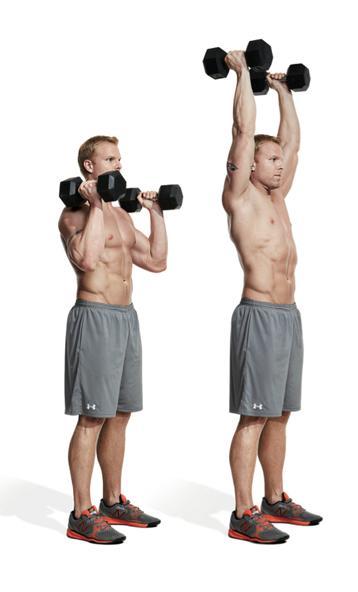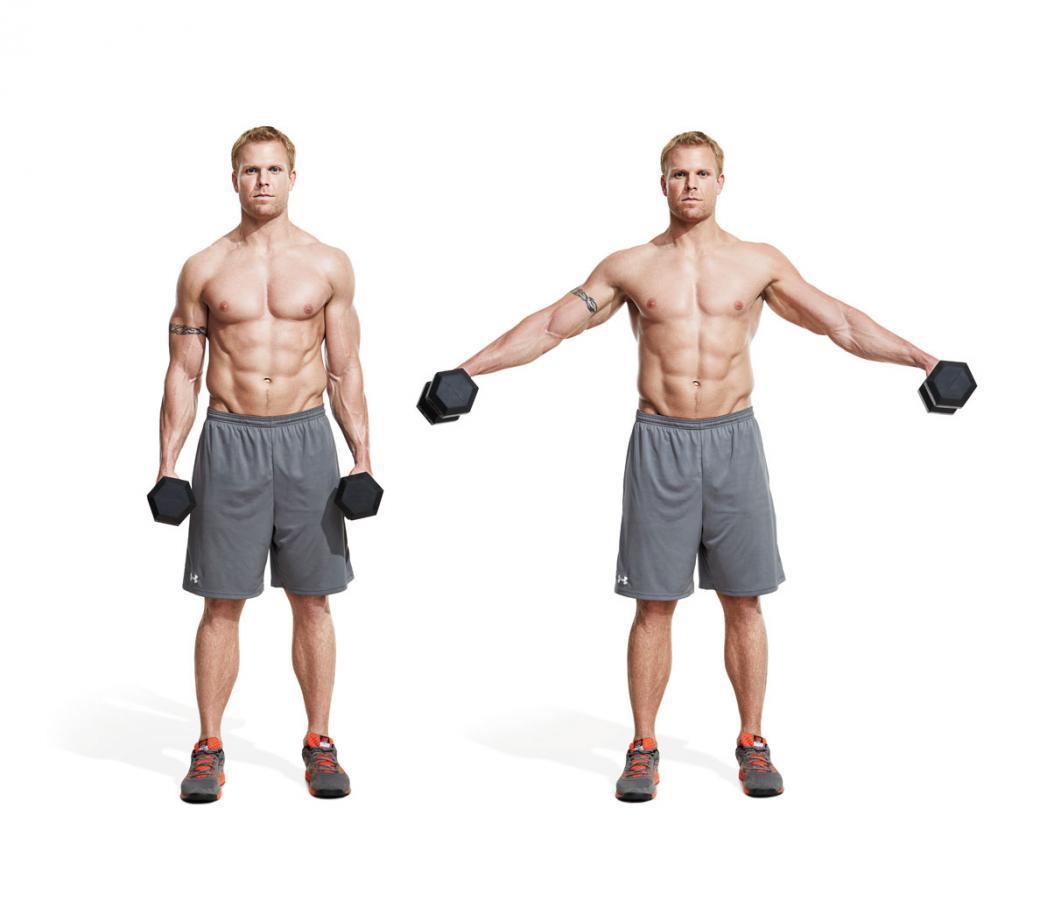The first image is the image on the left, the second image is the image on the right. Analyze the images presented: Is the assertion "There is both a man and a woman demonstrating weight lifting techniques." valid? Answer yes or no. No. 